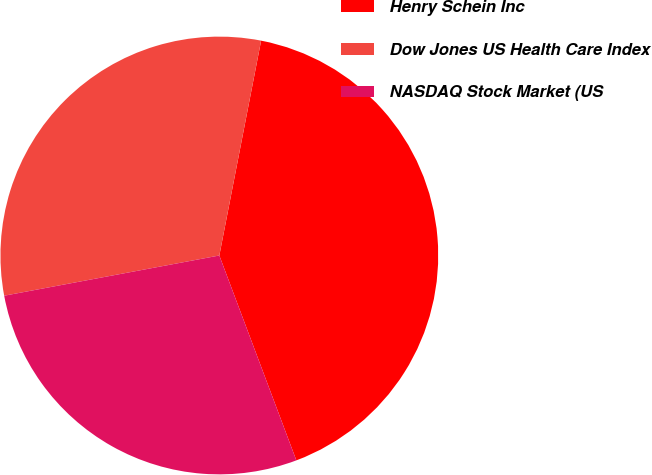Convert chart to OTSL. <chart><loc_0><loc_0><loc_500><loc_500><pie_chart><fcel>Henry Schein Inc<fcel>Dow Jones US Health Care Index<fcel>NASDAQ Stock Market (US<nl><fcel>41.22%<fcel>31.0%<fcel>27.78%<nl></chart> 